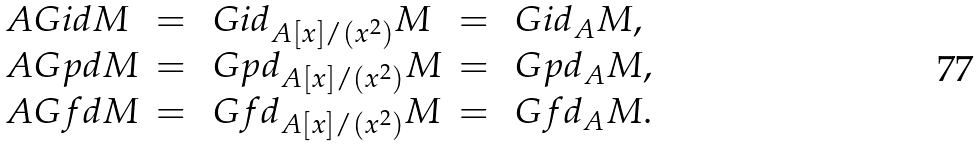<formula> <loc_0><loc_0><loc_500><loc_500>\begin{array} { l c l c l } \ A G i d M & = & \ G i d _ { A [ x ] / ( x ^ { 2 } ) } M & = & \ G i d _ { A } M , \\ \ A G p d M & = & \ G p d _ { A [ x ] / ( x ^ { 2 } ) } M & = & \ G p d _ { A } M , \\ \ A G f d M & = & \ G f d _ { A [ x ] / ( x ^ { 2 } ) } M & = & \ G f d _ { A } M . \end{array}</formula> 